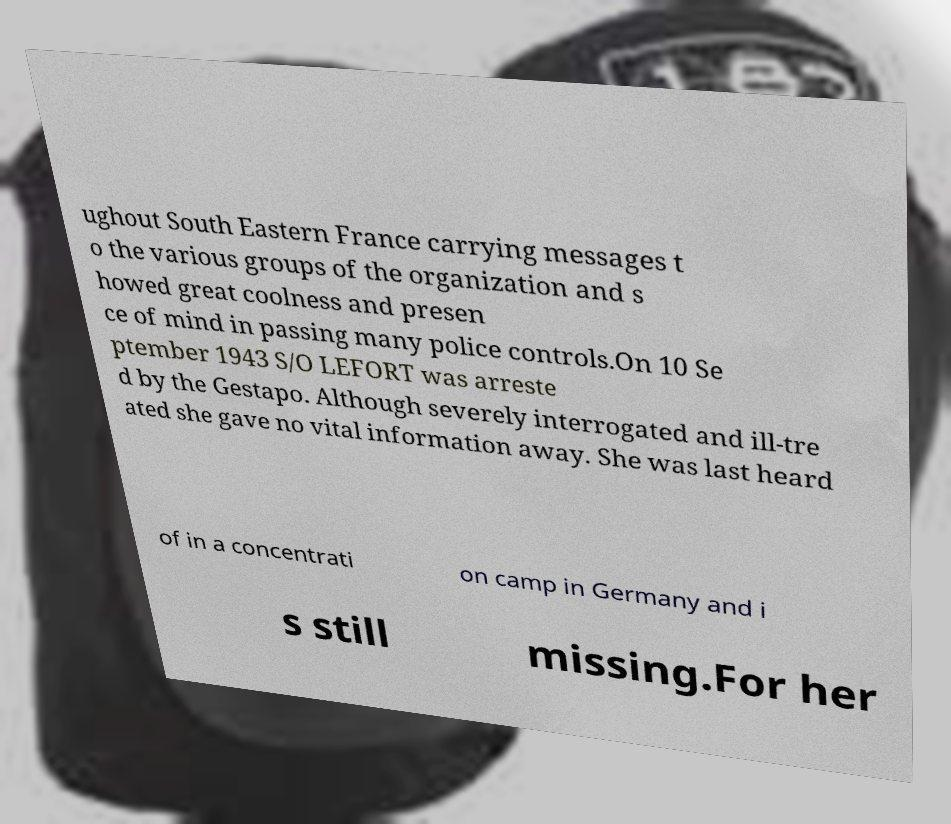What messages or text are displayed in this image? I need them in a readable, typed format. ughout South Eastern France carrying messages t o the various groups of the organization and s howed great coolness and presen ce of mind in passing many police controls.On 10 Se ptember 1943 S/O LEFORT was arreste d by the Gestapo. Although severely interrogated and ill-tre ated she gave no vital information away. She was last heard of in a concentrati on camp in Germany and i s still missing.For her 